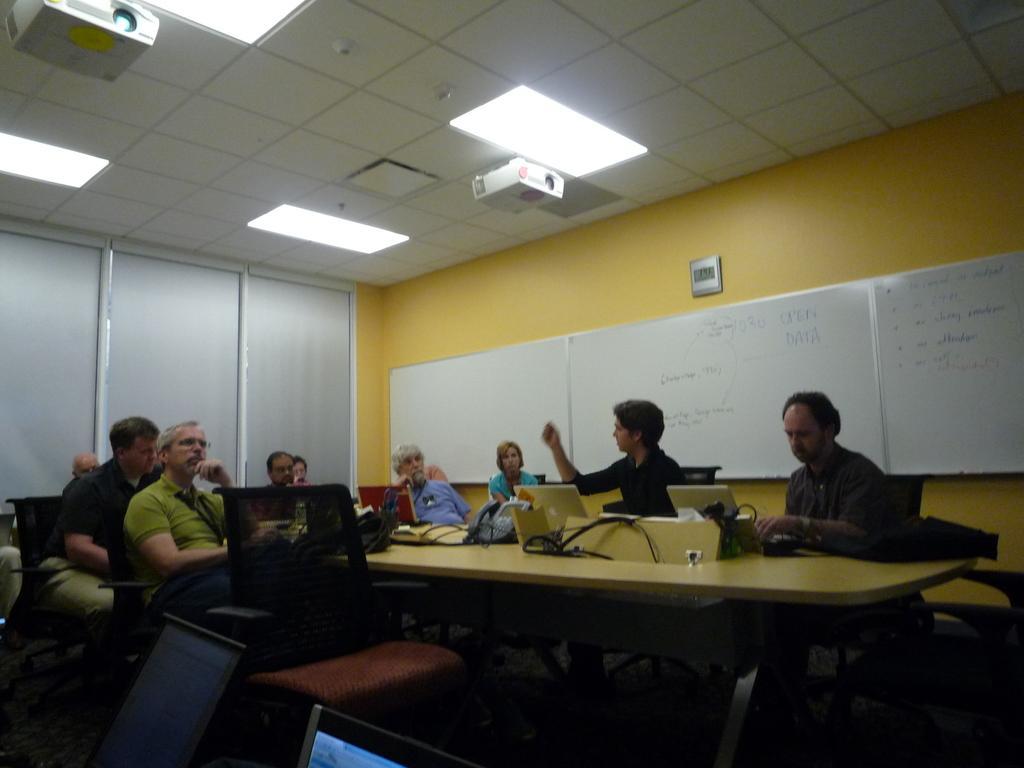Describe this image in one or two sentences. people are sitting on the chairs operating laptops. behind them at the right there are white boards. at the top there is projector and lights. 